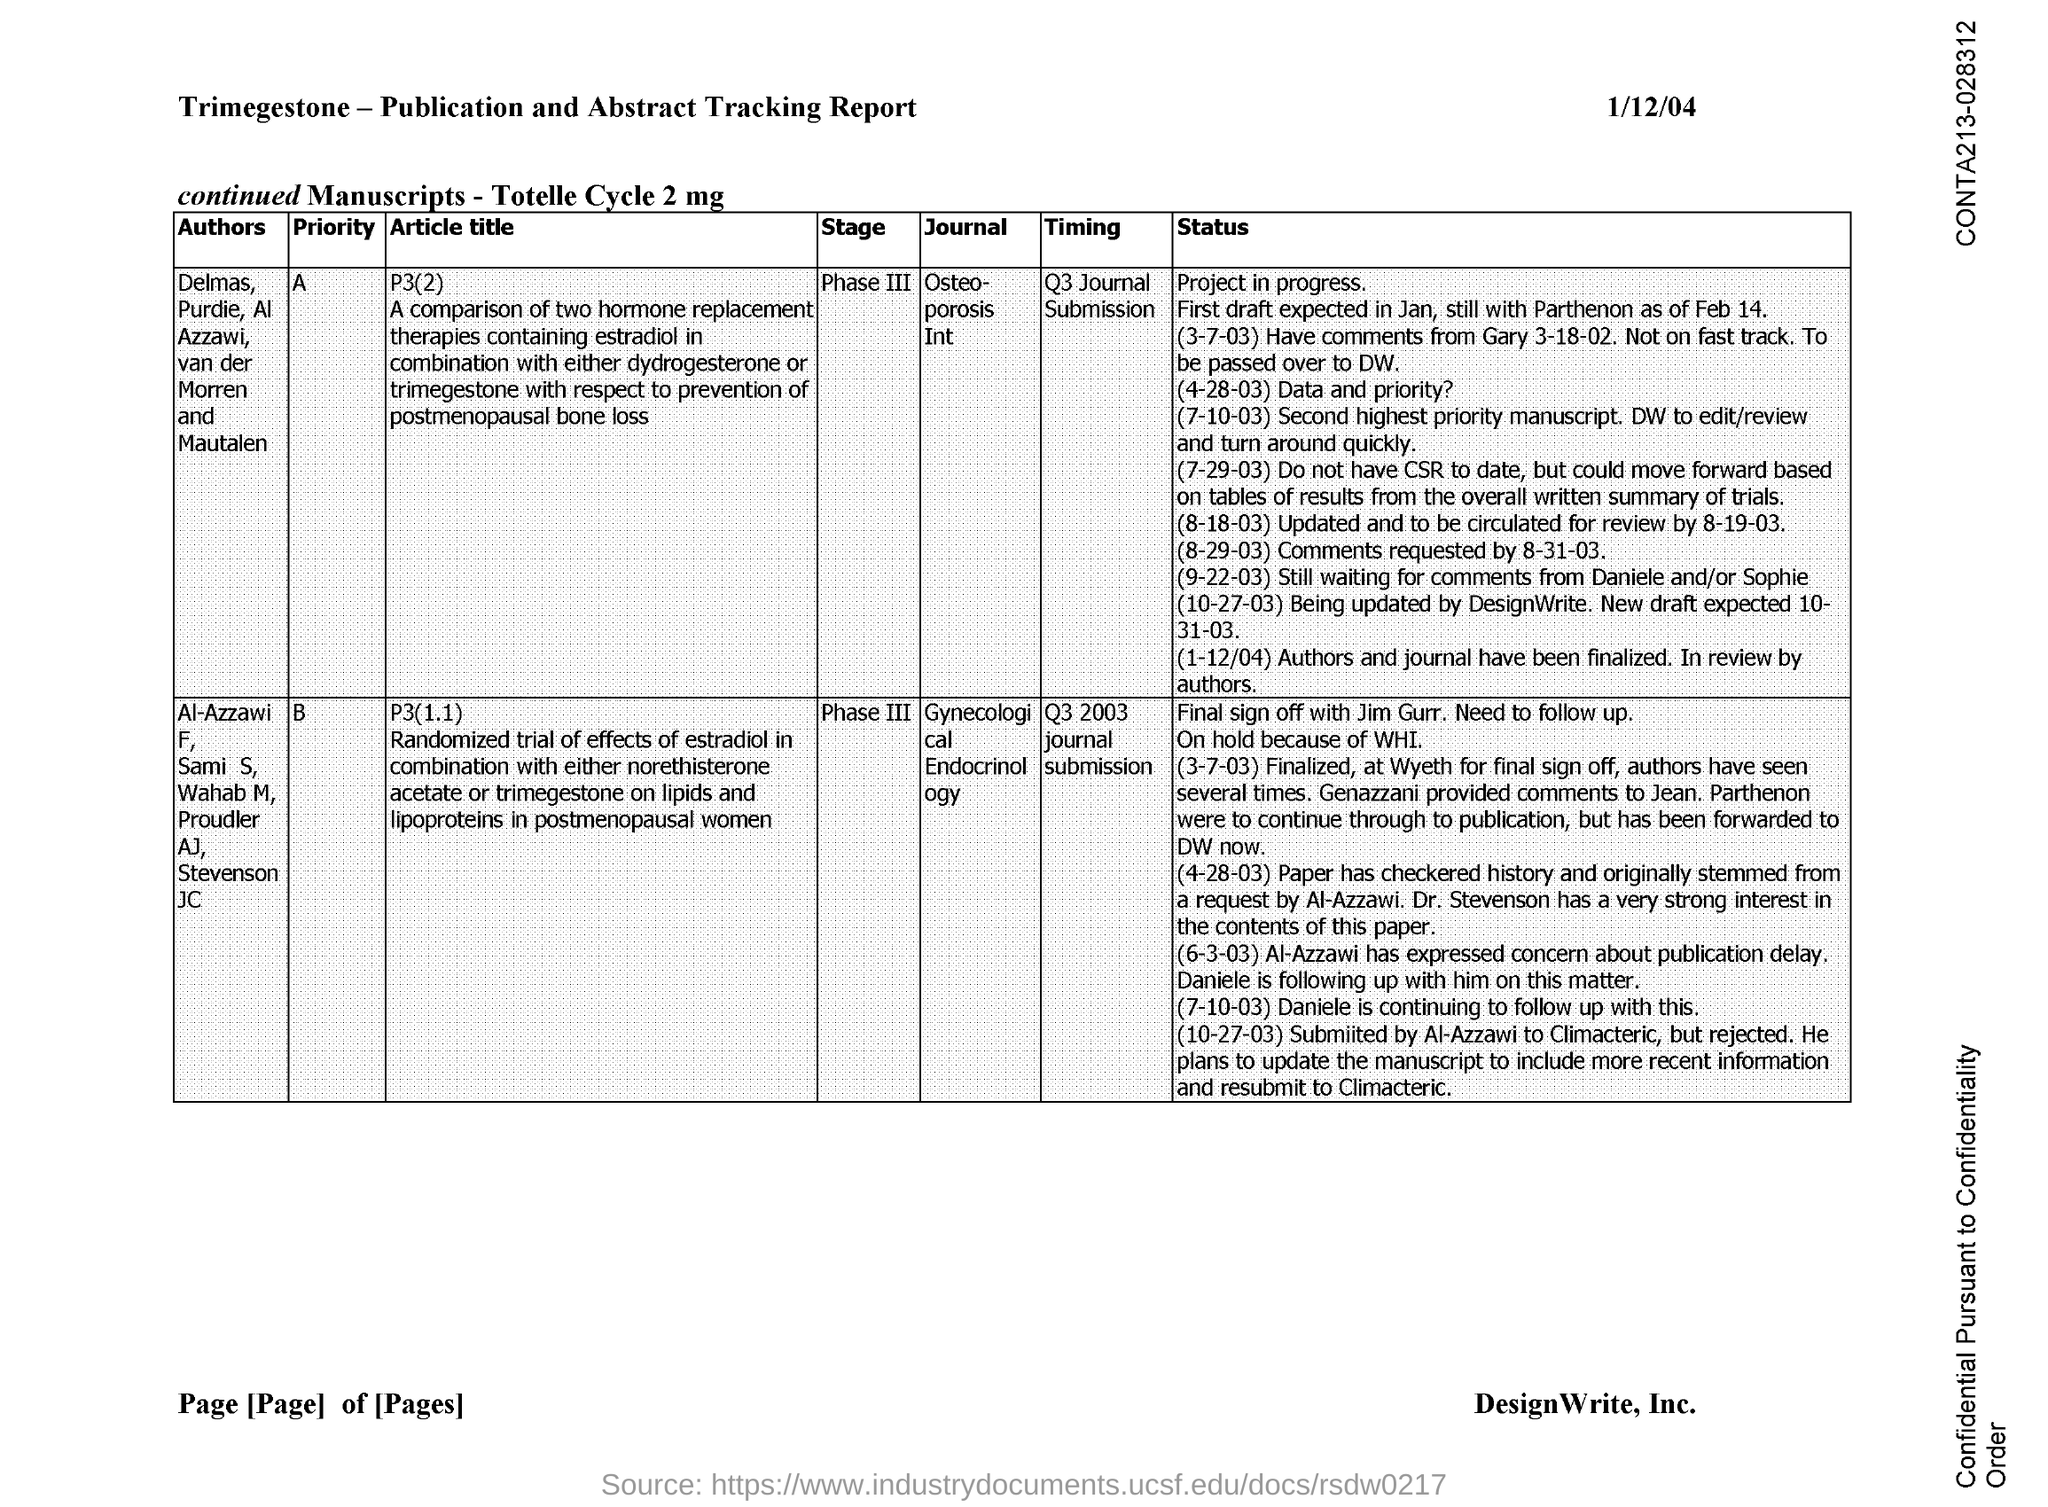Give some essential details in this illustration. The Journal of Osteoporosis, Q3 Journal Submission, is the timing for the journal. The Journal of Gynecological Endocrinology was submitted for publication in Q3 2003. 